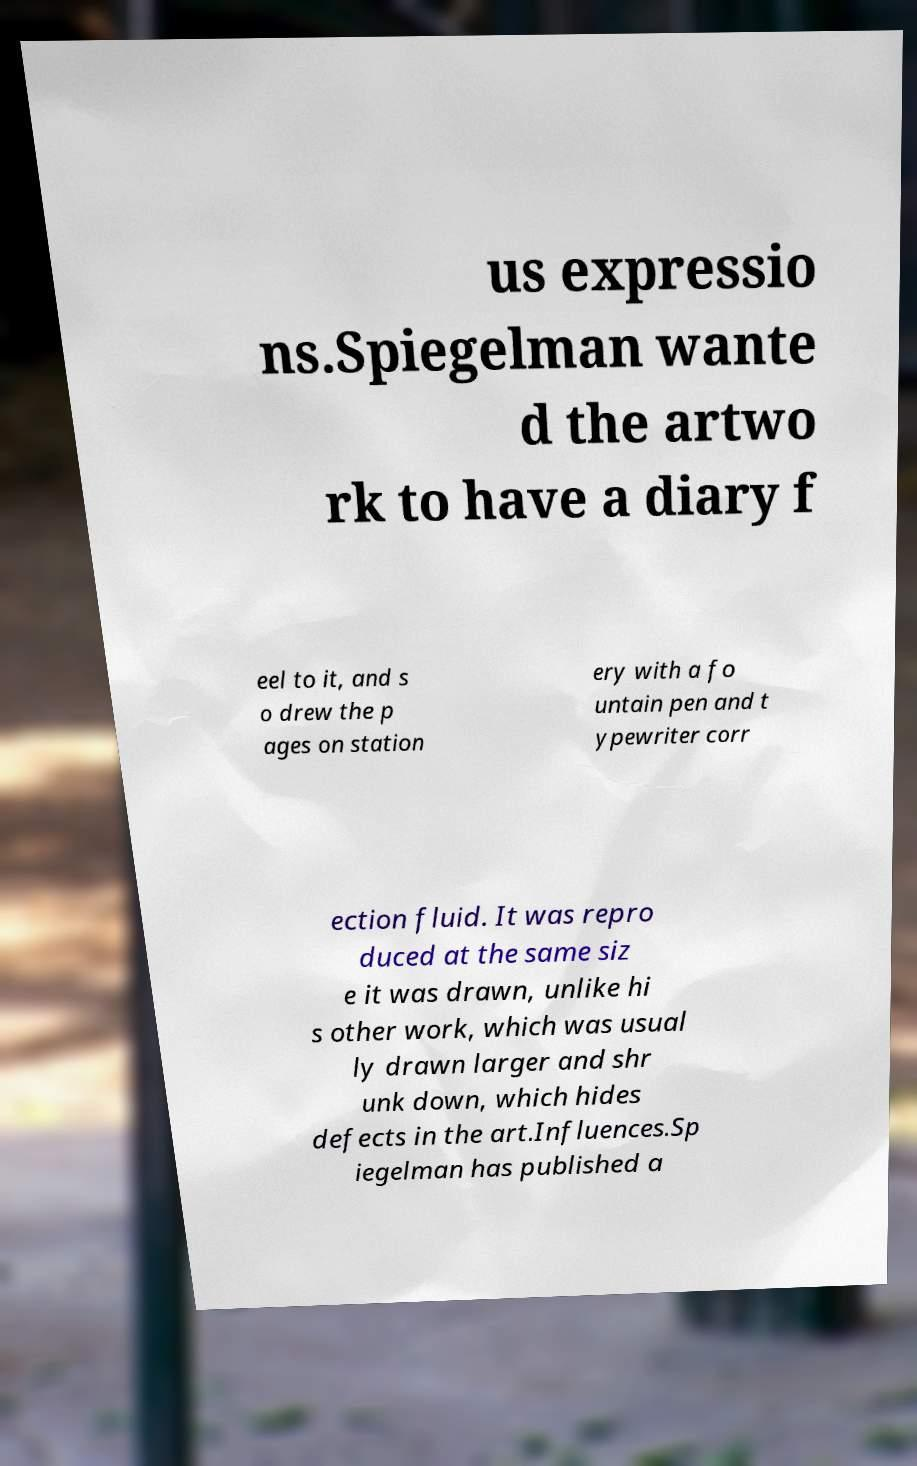Could you extract and type out the text from this image? us expressio ns.Spiegelman wante d the artwo rk to have a diary f eel to it, and s o drew the p ages on station ery with a fo untain pen and t ypewriter corr ection fluid. It was repro duced at the same siz e it was drawn, unlike hi s other work, which was usual ly drawn larger and shr unk down, which hides defects in the art.Influences.Sp iegelman has published a 